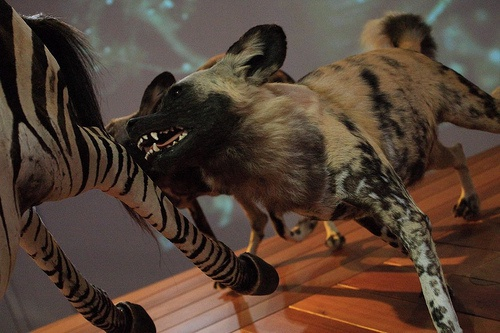Describe the objects in this image and their specific colors. I can see dog in black, maroon, and gray tones and zebra in black, maroon, and gray tones in this image. 